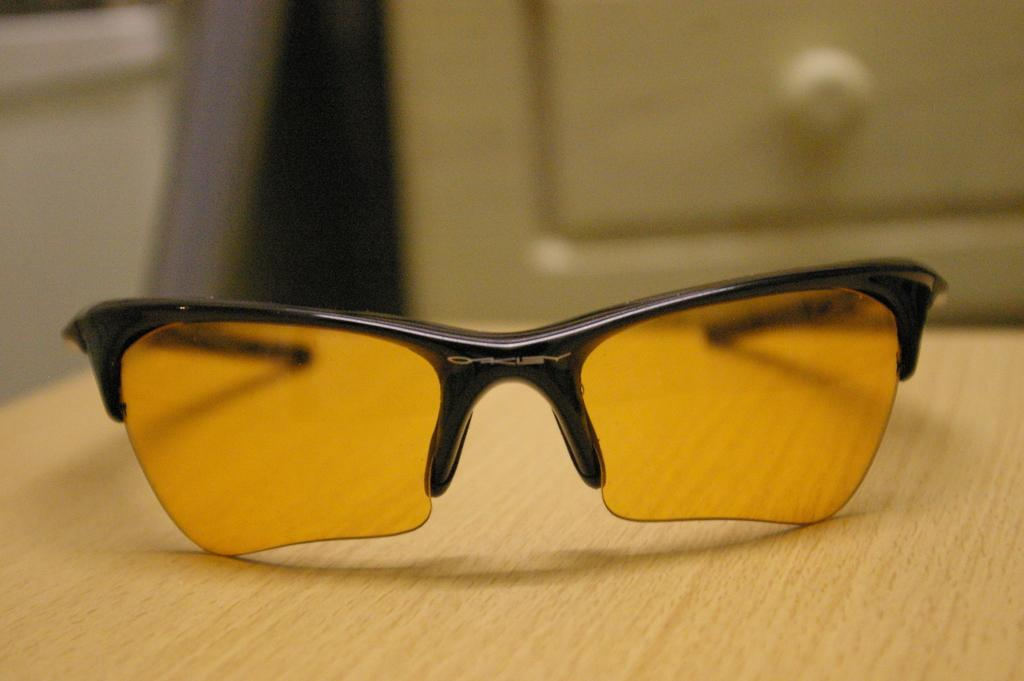What type of protective eyewear is visible in the image? There are goggles in the image. What color is the surface on which the goggles are placed? The goggles are on a brown color surface. Can you describe the background of the image? The background of the image is blurred. What type of vegetable is being used as a wishing well in the image? There is no vegetable or wishing well present in the image; it only features goggles on a brown surface with a blurred background. 